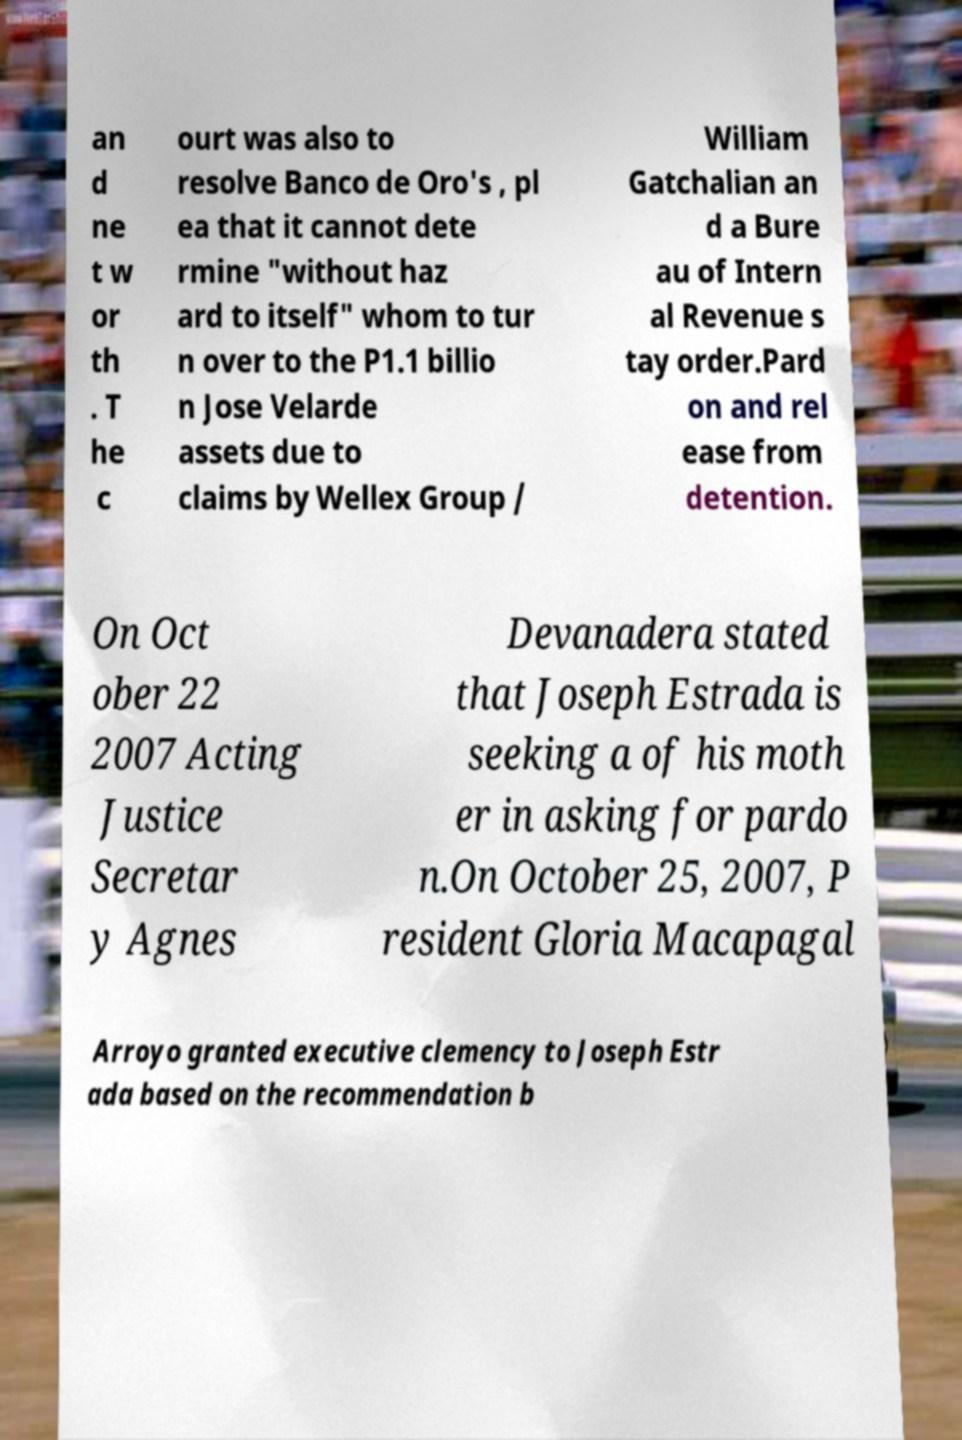There's text embedded in this image that I need extracted. Can you transcribe it verbatim? an d ne t w or th . T he c ourt was also to resolve Banco de Oro's , pl ea that it cannot dete rmine "without haz ard to itself" whom to tur n over to the P1.1 billio n Jose Velarde assets due to claims by Wellex Group / William Gatchalian an d a Bure au of Intern al Revenue s tay order.Pard on and rel ease from detention. On Oct ober 22 2007 Acting Justice Secretar y Agnes Devanadera stated that Joseph Estrada is seeking a of his moth er in asking for pardo n.On October 25, 2007, P resident Gloria Macapagal Arroyo granted executive clemency to Joseph Estr ada based on the recommendation b 